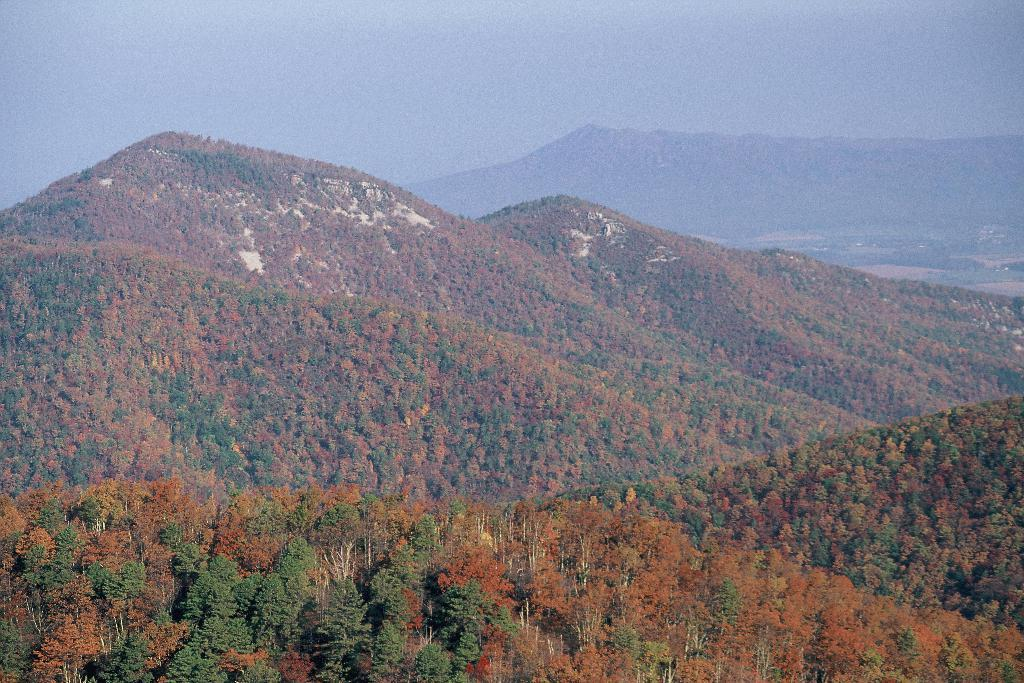What type of natural formation can be seen in the image? There are mountains in the image. What covers the mountains in the image? The mountains are covered with trees. What is visible at the top of the image? The sky is visible at the top of the image. What color is the shirt worn by the person on the stage in the image? There is no person wearing a shirt on a stage in the image; it only features mountains covered with trees and the sky. 